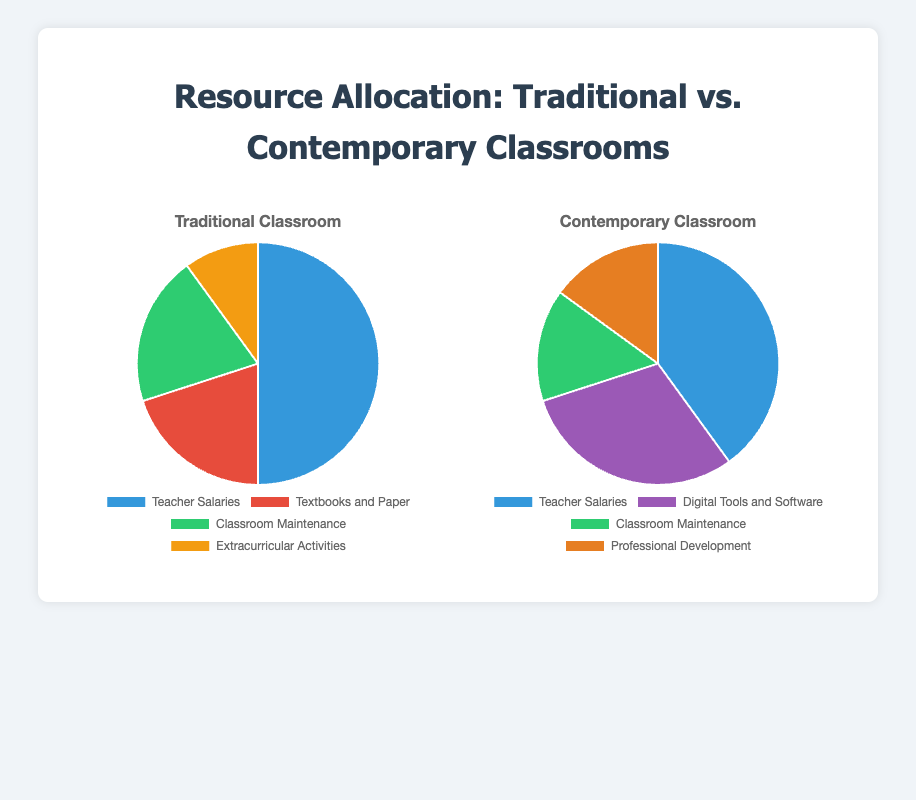What percentage difference is there between teacher salaries in traditional and contemporary classrooms? In traditional classrooms, teacher salaries account for 50% of the allocation, while in contemporary classrooms, it's 40%. The percentage difference is calculated as (50 - 40) / 50 * 100 = 20%.
Answer: 20% Which classroom type allocates more resources to maintenance, and by how much? Traditional classrooms allocate 20% to maintenance, whereas contemporary classrooms allocate 15%. The difference is 20% - 15% = 5%.
Answer: Traditional by 5% In a traditional classroom, what is the combined percentage of resources allocated to textbooks and paper and extracurricular activities? Textbooks and paper account for 20%, and extracurricular activities account for 10%. Combined, this is 20% + 10% = 30%.
Answer: 30% What is the percentage allocation difference for classroom maintenance between the two classroom types? Traditional classrooms allocate 20% to maintenance, while contemporary classrooms allocate 15%. The difference is 20% - 15% = 5%.
Answer: 5% Which allocation category in the contemporary classroom has the same percentage as one in the traditional classroom, and what is it? In contemporary classrooms, professional development and classroom maintenance both account for 15%, which matches the combined percentage of textbooks and paper (20%) and extracurricular activities (10%) in traditional classrooms, totaling 30%. Therefore, there is a redistribution but a similar total percentage allocation for non-teacher-related expenses.
Answer: Classroom maintenance (15%) Compare the allocation for digital tools and software in contemporary classrooms with that for textbooks and paper in traditional classrooms. What is the difference in percentage? Contemporary classrooms allocate 30% to digital tools and software, while traditional classrooms allocate 20% to textbooks and paper. The difference is 30% - 20% = 10%.
Answer: 10% If you decide to combine classroom maintenance and extracurricular activities in traditional classrooms, what percentage of the total resources is used for these two categories? Maintenance is 20%, and extracurricular activities are 10%. Combined, it's 20% + 10% = 30%.
Answer: 30% Looking at teacher salaries, what percentage change would you need to match the contemporary allocation with the traditional one? Teacher salaries in traditional classrooms are at 50%, while in contemporary classrooms at 40%. To match the traditional allocation, contemporary classrooms would need a (50 - 40) / 40 * 100 = 25% increase in allocation for teacher salaries.
Answer: 25% Which visual attribute difference between traditional and contemporary classrooms’ pie charts is most noticeable concerning digital tools vs. textbooks? In traditional classrooms, there is no allocation for digital tools, while contemporary classrooms allocate 30% to digital tools. This category is very prominent in the contemporary pie chart but non-existent in the traditional one.
Answer: Digital tools (contemporary) vs. textbooks (traditional) In contemporary classrooms, what is the combined percentage of resources allocated to items other than teacher salaries? Teacher salaries are allocated 40%, so the rest is 100% - 40% = 60%.
Answer: 60% 